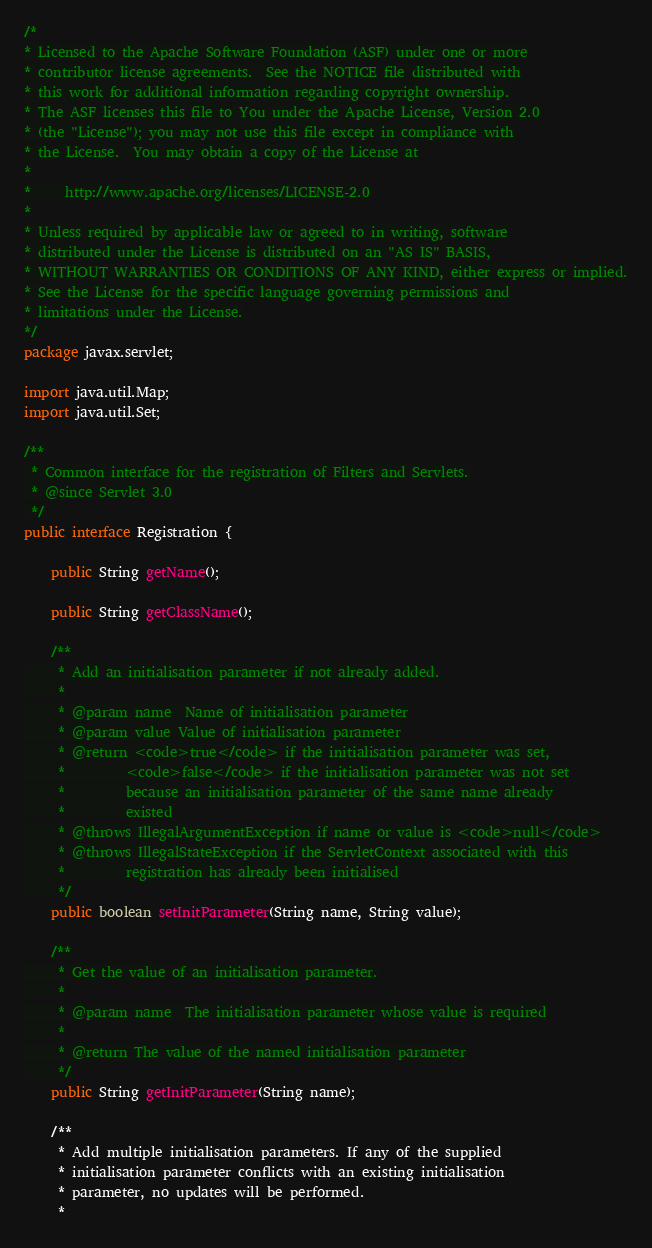Convert code to text. <code><loc_0><loc_0><loc_500><loc_500><_Java_>/*
* Licensed to the Apache Software Foundation (ASF) under one or more
* contributor license agreements.  See the NOTICE file distributed with
* this work for additional information regarding copyright ownership.
* The ASF licenses this file to You under the Apache License, Version 2.0
* (the "License"); you may not use this file except in compliance with
* the License.  You may obtain a copy of the License at
*
*     http://www.apache.org/licenses/LICENSE-2.0
*
* Unless required by applicable law or agreed to in writing, software
* distributed under the License is distributed on an "AS IS" BASIS,
* WITHOUT WARRANTIES OR CONDITIONS OF ANY KIND, either express or implied.
* See the License for the specific language governing permissions and
* limitations under the License.
*/
package javax.servlet;

import java.util.Map;
import java.util.Set;

/**
 * Common interface for the registration of Filters and Servlets.
 * @since Servlet 3.0
 */
public interface Registration {

    public String getName();

    public String getClassName();

    /**
     * Add an initialisation parameter if not already added.
     *
     * @param name  Name of initialisation parameter
     * @param value Value of initialisation parameter
     * @return <code>true</code> if the initialisation parameter was set,
     *         <code>false</code> if the initialisation parameter was not set
     *         because an initialisation parameter of the same name already
     *         existed
     * @throws IllegalArgumentException if name or value is <code>null</code>
     * @throws IllegalStateException if the ServletContext associated with this
     *         registration has already been initialised
     */
    public boolean setInitParameter(String name, String value);

    /**
     * Get the value of an initialisation parameter.
     *
     * @param name  The initialisation parameter whose value is required
     *
     * @return The value of the named initialisation parameter
     */
    public String getInitParameter(String name);

    /**
     * Add multiple initialisation parameters. If any of the supplied
     * initialisation parameter conflicts with an existing initialisation
     * parameter, no updates will be performed.
     *</code> 